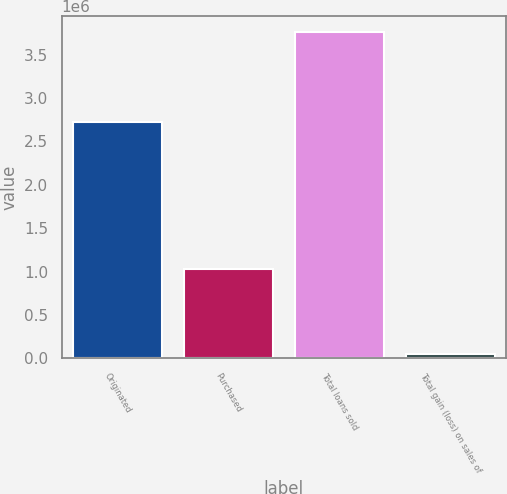Convert chart. <chart><loc_0><loc_0><loc_500><loc_500><bar_chart><fcel>Originated<fcel>Purchased<fcel>Total loans sold<fcel>Total gain (loss) on sales of<nl><fcel>2.72809e+06<fcel>1.02875e+06<fcel>3.75684e+06<fcel>53639<nl></chart> 